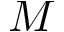Convert formula to latex. <formula><loc_0><loc_0><loc_500><loc_500>M</formula> 